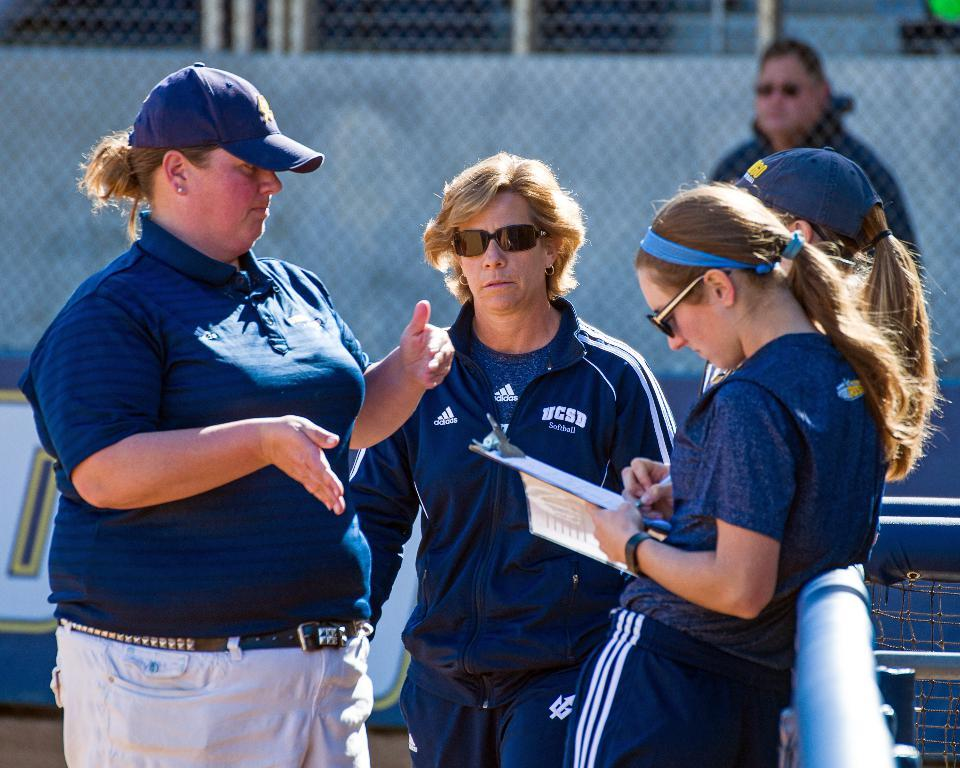<image>
Summarize the visual content of the image. Two women talk with two girls, one woman wears a jacket that reads UCSD softball. 